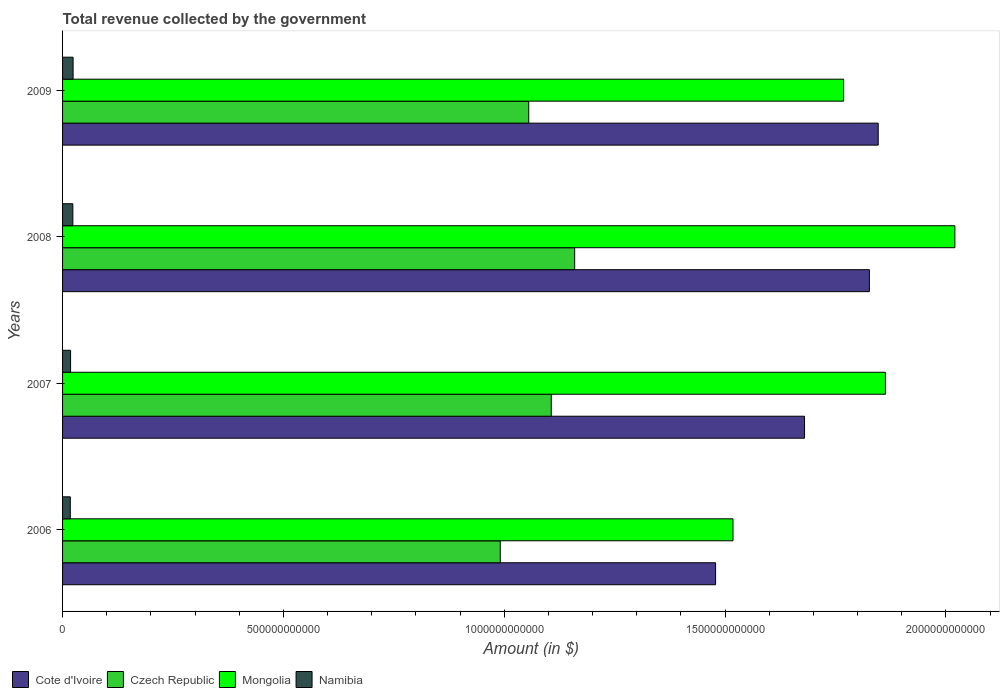How many different coloured bars are there?
Provide a succinct answer. 4. What is the total revenue collected by the government in Cote d'Ivoire in 2009?
Your answer should be very brief. 1.85e+12. Across all years, what is the maximum total revenue collected by the government in Mongolia?
Your response must be concise. 2.02e+12. Across all years, what is the minimum total revenue collected by the government in Czech Republic?
Offer a terse response. 9.91e+11. What is the total total revenue collected by the government in Czech Republic in the graph?
Provide a succinct answer. 4.31e+12. What is the difference between the total revenue collected by the government in Czech Republic in 2007 and that in 2008?
Give a very brief answer. -5.30e+1. What is the difference between the total revenue collected by the government in Cote d'Ivoire in 2006 and the total revenue collected by the government in Mongolia in 2007?
Keep it short and to the point. -3.84e+11. What is the average total revenue collected by the government in Cote d'Ivoire per year?
Ensure brevity in your answer.  1.71e+12. In the year 2008, what is the difference between the total revenue collected by the government in Cote d'Ivoire and total revenue collected by the government in Czech Republic?
Provide a short and direct response. 6.67e+11. In how many years, is the total revenue collected by the government in Mongolia greater than 300000000000 $?
Make the answer very short. 4. What is the ratio of the total revenue collected by the government in Cote d'Ivoire in 2008 to that in 2009?
Give a very brief answer. 0.99. Is the total revenue collected by the government in Czech Republic in 2007 less than that in 2008?
Ensure brevity in your answer.  Yes. What is the difference between the highest and the second highest total revenue collected by the government in Czech Republic?
Keep it short and to the point. 5.30e+1. What is the difference between the highest and the lowest total revenue collected by the government in Mongolia?
Your response must be concise. 5.02e+11. In how many years, is the total revenue collected by the government in Namibia greater than the average total revenue collected by the government in Namibia taken over all years?
Keep it short and to the point. 2. Is the sum of the total revenue collected by the government in Cote d'Ivoire in 2007 and 2009 greater than the maximum total revenue collected by the government in Mongolia across all years?
Offer a terse response. Yes. Is it the case that in every year, the sum of the total revenue collected by the government in Namibia and total revenue collected by the government in Czech Republic is greater than the sum of total revenue collected by the government in Cote d'Ivoire and total revenue collected by the government in Mongolia?
Your response must be concise. No. What does the 1st bar from the top in 2006 represents?
Offer a terse response. Namibia. What does the 3rd bar from the bottom in 2007 represents?
Provide a short and direct response. Mongolia. How many bars are there?
Provide a succinct answer. 16. How many years are there in the graph?
Provide a short and direct response. 4. What is the difference between two consecutive major ticks on the X-axis?
Your answer should be very brief. 5.00e+11. Are the values on the major ticks of X-axis written in scientific E-notation?
Your response must be concise. No. Does the graph contain any zero values?
Ensure brevity in your answer.  No. Does the graph contain grids?
Your answer should be compact. No. Where does the legend appear in the graph?
Provide a short and direct response. Bottom left. What is the title of the graph?
Ensure brevity in your answer.  Total revenue collected by the government. Does "Euro area" appear as one of the legend labels in the graph?
Make the answer very short. No. What is the label or title of the X-axis?
Your answer should be very brief. Amount (in $). What is the Amount (in $) of Cote d'Ivoire in 2006?
Keep it short and to the point. 1.48e+12. What is the Amount (in $) of Czech Republic in 2006?
Offer a terse response. 9.91e+11. What is the Amount (in $) in Mongolia in 2006?
Offer a very short reply. 1.52e+12. What is the Amount (in $) in Namibia in 2006?
Your answer should be very brief. 1.75e+1. What is the Amount (in $) in Cote d'Ivoire in 2007?
Provide a short and direct response. 1.68e+12. What is the Amount (in $) in Czech Republic in 2007?
Keep it short and to the point. 1.11e+12. What is the Amount (in $) in Mongolia in 2007?
Provide a succinct answer. 1.86e+12. What is the Amount (in $) in Namibia in 2007?
Keep it short and to the point. 1.82e+1. What is the Amount (in $) in Cote d'Ivoire in 2008?
Offer a very short reply. 1.83e+12. What is the Amount (in $) of Czech Republic in 2008?
Provide a succinct answer. 1.16e+12. What is the Amount (in $) of Mongolia in 2008?
Your response must be concise. 2.02e+12. What is the Amount (in $) in Namibia in 2008?
Give a very brief answer. 2.33e+1. What is the Amount (in $) in Cote d'Ivoire in 2009?
Provide a succinct answer. 1.85e+12. What is the Amount (in $) of Czech Republic in 2009?
Provide a short and direct response. 1.06e+12. What is the Amount (in $) in Mongolia in 2009?
Ensure brevity in your answer.  1.77e+12. What is the Amount (in $) in Namibia in 2009?
Make the answer very short. 2.38e+1. Across all years, what is the maximum Amount (in $) in Cote d'Ivoire?
Give a very brief answer. 1.85e+12. Across all years, what is the maximum Amount (in $) of Czech Republic?
Ensure brevity in your answer.  1.16e+12. Across all years, what is the maximum Amount (in $) of Mongolia?
Your answer should be very brief. 2.02e+12. Across all years, what is the maximum Amount (in $) of Namibia?
Ensure brevity in your answer.  2.38e+1. Across all years, what is the minimum Amount (in $) in Cote d'Ivoire?
Make the answer very short. 1.48e+12. Across all years, what is the minimum Amount (in $) of Czech Republic?
Ensure brevity in your answer.  9.91e+11. Across all years, what is the minimum Amount (in $) in Mongolia?
Keep it short and to the point. 1.52e+12. Across all years, what is the minimum Amount (in $) of Namibia?
Provide a succinct answer. 1.75e+1. What is the total Amount (in $) of Cote d'Ivoire in the graph?
Give a very brief answer. 6.83e+12. What is the total Amount (in $) in Czech Republic in the graph?
Keep it short and to the point. 4.31e+12. What is the total Amount (in $) of Mongolia in the graph?
Offer a terse response. 7.17e+12. What is the total Amount (in $) in Namibia in the graph?
Your response must be concise. 8.28e+1. What is the difference between the Amount (in $) in Cote d'Ivoire in 2006 and that in 2007?
Make the answer very short. -2.01e+11. What is the difference between the Amount (in $) of Czech Republic in 2006 and that in 2007?
Offer a terse response. -1.15e+11. What is the difference between the Amount (in $) of Mongolia in 2006 and that in 2007?
Your answer should be very brief. -3.45e+11. What is the difference between the Amount (in $) in Namibia in 2006 and that in 2007?
Make the answer very short. -6.34e+08. What is the difference between the Amount (in $) of Cote d'Ivoire in 2006 and that in 2008?
Your response must be concise. -3.48e+11. What is the difference between the Amount (in $) of Czech Republic in 2006 and that in 2008?
Give a very brief answer. -1.68e+11. What is the difference between the Amount (in $) of Mongolia in 2006 and that in 2008?
Make the answer very short. -5.02e+11. What is the difference between the Amount (in $) of Namibia in 2006 and that in 2008?
Your answer should be very brief. -5.80e+09. What is the difference between the Amount (in $) of Cote d'Ivoire in 2006 and that in 2009?
Your answer should be very brief. -3.68e+11. What is the difference between the Amount (in $) of Czech Republic in 2006 and that in 2009?
Offer a terse response. -6.45e+1. What is the difference between the Amount (in $) of Mongolia in 2006 and that in 2009?
Ensure brevity in your answer.  -2.51e+11. What is the difference between the Amount (in $) in Namibia in 2006 and that in 2009?
Provide a succinct answer. -6.33e+09. What is the difference between the Amount (in $) of Cote d'Ivoire in 2007 and that in 2008?
Ensure brevity in your answer.  -1.47e+11. What is the difference between the Amount (in $) in Czech Republic in 2007 and that in 2008?
Make the answer very short. -5.30e+1. What is the difference between the Amount (in $) in Mongolia in 2007 and that in 2008?
Make the answer very short. -1.57e+11. What is the difference between the Amount (in $) in Namibia in 2007 and that in 2008?
Offer a very short reply. -5.16e+09. What is the difference between the Amount (in $) in Cote d'Ivoire in 2007 and that in 2009?
Offer a terse response. -1.67e+11. What is the difference between the Amount (in $) in Czech Republic in 2007 and that in 2009?
Your answer should be compact. 5.09e+1. What is the difference between the Amount (in $) of Mongolia in 2007 and that in 2009?
Make the answer very short. 9.45e+1. What is the difference between the Amount (in $) in Namibia in 2007 and that in 2009?
Your answer should be very brief. -5.70e+09. What is the difference between the Amount (in $) of Cote d'Ivoire in 2008 and that in 2009?
Provide a short and direct response. -2.00e+1. What is the difference between the Amount (in $) in Czech Republic in 2008 and that in 2009?
Provide a succinct answer. 1.04e+11. What is the difference between the Amount (in $) of Mongolia in 2008 and that in 2009?
Your answer should be very brief. 2.52e+11. What is the difference between the Amount (in $) in Namibia in 2008 and that in 2009?
Make the answer very short. -5.30e+08. What is the difference between the Amount (in $) of Cote d'Ivoire in 2006 and the Amount (in $) of Czech Republic in 2007?
Your response must be concise. 3.72e+11. What is the difference between the Amount (in $) in Cote d'Ivoire in 2006 and the Amount (in $) in Mongolia in 2007?
Make the answer very short. -3.84e+11. What is the difference between the Amount (in $) in Cote d'Ivoire in 2006 and the Amount (in $) in Namibia in 2007?
Give a very brief answer. 1.46e+12. What is the difference between the Amount (in $) of Czech Republic in 2006 and the Amount (in $) of Mongolia in 2007?
Your response must be concise. -8.72e+11. What is the difference between the Amount (in $) of Czech Republic in 2006 and the Amount (in $) of Namibia in 2007?
Your response must be concise. 9.73e+11. What is the difference between the Amount (in $) of Mongolia in 2006 and the Amount (in $) of Namibia in 2007?
Make the answer very short. 1.50e+12. What is the difference between the Amount (in $) of Cote d'Ivoire in 2006 and the Amount (in $) of Czech Republic in 2008?
Keep it short and to the point. 3.19e+11. What is the difference between the Amount (in $) in Cote d'Ivoire in 2006 and the Amount (in $) in Mongolia in 2008?
Give a very brief answer. -5.42e+11. What is the difference between the Amount (in $) in Cote d'Ivoire in 2006 and the Amount (in $) in Namibia in 2008?
Your answer should be very brief. 1.46e+12. What is the difference between the Amount (in $) in Czech Republic in 2006 and the Amount (in $) in Mongolia in 2008?
Offer a terse response. -1.03e+12. What is the difference between the Amount (in $) in Czech Republic in 2006 and the Amount (in $) in Namibia in 2008?
Offer a terse response. 9.68e+11. What is the difference between the Amount (in $) of Mongolia in 2006 and the Amount (in $) of Namibia in 2008?
Provide a succinct answer. 1.49e+12. What is the difference between the Amount (in $) in Cote d'Ivoire in 2006 and the Amount (in $) in Czech Republic in 2009?
Give a very brief answer. 4.23e+11. What is the difference between the Amount (in $) in Cote d'Ivoire in 2006 and the Amount (in $) in Mongolia in 2009?
Your answer should be compact. -2.90e+11. What is the difference between the Amount (in $) of Cote d'Ivoire in 2006 and the Amount (in $) of Namibia in 2009?
Offer a terse response. 1.45e+12. What is the difference between the Amount (in $) in Czech Republic in 2006 and the Amount (in $) in Mongolia in 2009?
Ensure brevity in your answer.  -7.77e+11. What is the difference between the Amount (in $) of Czech Republic in 2006 and the Amount (in $) of Namibia in 2009?
Your answer should be very brief. 9.67e+11. What is the difference between the Amount (in $) in Mongolia in 2006 and the Amount (in $) in Namibia in 2009?
Give a very brief answer. 1.49e+12. What is the difference between the Amount (in $) in Cote d'Ivoire in 2007 and the Amount (in $) in Czech Republic in 2008?
Make the answer very short. 5.20e+11. What is the difference between the Amount (in $) in Cote d'Ivoire in 2007 and the Amount (in $) in Mongolia in 2008?
Offer a terse response. -3.40e+11. What is the difference between the Amount (in $) in Cote d'Ivoire in 2007 and the Amount (in $) in Namibia in 2008?
Offer a very short reply. 1.66e+12. What is the difference between the Amount (in $) of Czech Republic in 2007 and the Amount (in $) of Mongolia in 2008?
Make the answer very short. -9.14e+11. What is the difference between the Amount (in $) of Czech Republic in 2007 and the Amount (in $) of Namibia in 2008?
Your answer should be compact. 1.08e+12. What is the difference between the Amount (in $) of Mongolia in 2007 and the Amount (in $) of Namibia in 2008?
Give a very brief answer. 1.84e+12. What is the difference between the Amount (in $) in Cote d'Ivoire in 2007 and the Amount (in $) in Czech Republic in 2009?
Ensure brevity in your answer.  6.24e+11. What is the difference between the Amount (in $) of Cote d'Ivoire in 2007 and the Amount (in $) of Mongolia in 2009?
Give a very brief answer. -8.85e+1. What is the difference between the Amount (in $) in Cote d'Ivoire in 2007 and the Amount (in $) in Namibia in 2009?
Your answer should be compact. 1.66e+12. What is the difference between the Amount (in $) of Czech Republic in 2007 and the Amount (in $) of Mongolia in 2009?
Your answer should be compact. -6.62e+11. What is the difference between the Amount (in $) of Czech Republic in 2007 and the Amount (in $) of Namibia in 2009?
Your answer should be compact. 1.08e+12. What is the difference between the Amount (in $) of Mongolia in 2007 and the Amount (in $) of Namibia in 2009?
Provide a succinct answer. 1.84e+12. What is the difference between the Amount (in $) of Cote d'Ivoire in 2008 and the Amount (in $) of Czech Republic in 2009?
Offer a terse response. 7.71e+11. What is the difference between the Amount (in $) of Cote d'Ivoire in 2008 and the Amount (in $) of Mongolia in 2009?
Give a very brief answer. 5.83e+1. What is the difference between the Amount (in $) in Cote d'Ivoire in 2008 and the Amount (in $) in Namibia in 2009?
Your answer should be compact. 1.80e+12. What is the difference between the Amount (in $) of Czech Republic in 2008 and the Amount (in $) of Mongolia in 2009?
Keep it short and to the point. -6.09e+11. What is the difference between the Amount (in $) in Czech Republic in 2008 and the Amount (in $) in Namibia in 2009?
Provide a short and direct response. 1.14e+12. What is the difference between the Amount (in $) in Mongolia in 2008 and the Amount (in $) in Namibia in 2009?
Keep it short and to the point. 2.00e+12. What is the average Amount (in $) in Cote d'Ivoire per year?
Give a very brief answer. 1.71e+12. What is the average Amount (in $) of Czech Republic per year?
Provide a short and direct response. 1.08e+12. What is the average Amount (in $) in Mongolia per year?
Offer a terse response. 1.79e+12. What is the average Amount (in $) in Namibia per year?
Your response must be concise. 2.07e+1. In the year 2006, what is the difference between the Amount (in $) of Cote d'Ivoire and Amount (in $) of Czech Republic?
Offer a terse response. 4.88e+11. In the year 2006, what is the difference between the Amount (in $) in Cote d'Ivoire and Amount (in $) in Mongolia?
Offer a very short reply. -3.94e+1. In the year 2006, what is the difference between the Amount (in $) in Cote d'Ivoire and Amount (in $) in Namibia?
Your answer should be compact. 1.46e+12. In the year 2006, what is the difference between the Amount (in $) in Czech Republic and Amount (in $) in Mongolia?
Make the answer very short. -5.27e+11. In the year 2006, what is the difference between the Amount (in $) in Czech Republic and Amount (in $) in Namibia?
Your response must be concise. 9.73e+11. In the year 2006, what is the difference between the Amount (in $) in Mongolia and Amount (in $) in Namibia?
Ensure brevity in your answer.  1.50e+12. In the year 2007, what is the difference between the Amount (in $) in Cote d'Ivoire and Amount (in $) in Czech Republic?
Your response must be concise. 5.73e+11. In the year 2007, what is the difference between the Amount (in $) in Cote d'Ivoire and Amount (in $) in Mongolia?
Provide a succinct answer. -1.83e+11. In the year 2007, what is the difference between the Amount (in $) of Cote d'Ivoire and Amount (in $) of Namibia?
Offer a very short reply. 1.66e+12. In the year 2007, what is the difference between the Amount (in $) of Czech Republic and Amount (in $) of Mongolia?
Make the answer very short. -7.57e+11. In the year 2007, what is the difference between the Amount (in $) in Czech Republic and Amount (in $) in Namibia?
Provide a short and direct response. 1.09e+12. In the year 2007, what is the difference between the Amount (in $) in Mongolia and Amount (in $) in Namibia?
Keep it short and to the point. 1.84e+12. In the year 2008, what is the difference between the Amount (in $) in Cote d'Ivoire and Amount (in $) in Czech Republic?
Offer a very short reply. 6.67e+11. In the year 2008, what is the difference between the Amount (in $) in Cote d'Ivoire and Amount (in $) in Mongolia?
Offer a terse response. -1.94e+11. In the year 2008, what is the difference between the Amount (in $) of Cote d'Ivoire and Amount (in $) of Namibia?
Make the answer very short. 1.80e+12. In the year 2008, what is the difference between the Amount (in $) of Czech Republic and Amount (in $) of Mongolia?
Your response must be concise. -8.61e+11. In the year 2008, what is the difference between the Amount (in $) of Czech Republic and Amount (in $) of Namibia?
Make the answer very short. 1.14e+12. In the year 2008, what is the difference between the Amount (in $) in Mongolia and Amount (in $) in Namibia?
Ensure brevity in your answer.  2.00e+12. In the year 2009, what is the difference between the Amount (in $) of Cote d'Ivoire and Amount (in $) of Czech Republic?
Your answer should be compact. 7.91e+11. In the year 2009, what is the difference between the Amount (in $) of Cote d'Ivoire and Amount (in $) of Mongolia?
Make the answer very short. 7.83e+1. In the year 2009, what is the difference between the Amount (in $) of Cote d'Ivoire and Amount (in $) of Namibia?
Offer a terse response. 1.82e+12. In the year 2009, what is the difference between the Amount (in $) of Czech Republic and Amount (in $) of Mongolia?
Ensure brevity in your answer.  -7.13e+11. In the year 2009, what is the difference between the Amount (in $) of Czech Republic and Amount (in $) of Namibia?
Provide a short and direct response. 1.03e+12. In the year 2009, what is the difference between the Amount (in $) in Mongolia and Amount (in $) in Namibia?
Your response must be concise. 1.74e+12. What is the ratio of the Amount (in $) of Cote d'Ivoire in 2006 to that in 2007?
Provide a short and direct response. 0.88. What is the ratio of the Amount (in $) in Czech Republic in 2006 to that in 2007?
Provide a succinct answer. 0.9. What is the ratio of the Amount (in $) of Mongolia in 2006 to that in 2007?
Offer a very short reply. 0.81. What is the ratio of the Amount (in $) in Namibia in 2006 to that in 2007?
Keep it short and to the point. 0.97. What is the ratio of the Amount (in $) in Cote d'Ivoire in 2006 to that in 2008?
Your response must be concise. 0.81. What is the ratio of the Amount (in $) of Czech Republic in 2006 to that in 2008?
Give a very brief answer. 0.85. What is the ratio of the Amount (in $) in Mongolia in 2006 to that in 2008?
Your answer should be very brief. 0.75. What is the ratio of the Amount (in $) in Namibia in 2006 to that in 2008?
Provide a succinct answer. 0.75. What is the ratio of the Amount (in $) in Cote d'Ivoire in 2006 to that in 2009?
Make the answer very short. 0.8. What is the ratio of the Amount (in $) of Czech Republic in 2006 to that in 2009?
Your response must be concise. 0.94. What is the ratio of the Amount (in $) of Mongolia in 2006 to that in 2009?
Give a very brief answer. 0.86. What is the ratio of the Amount (in $) in Namibia in 2006 to that in 2009?
Ensure brevity in your answer.  0.73. What is the ratio of the Amount (in $) in Cote d'Ivoire in 2007 to that in 2008?
Offer a terse response. 0.92. What is the ratio of the Amount (in $) in Czech Republic in 2007 to that in 2008?
Provide a succinct answer. 0.95. What is the ratio of the Amount (in $) of Mongolia in 2007 to that in 2008?
Your response must be concise. 0.92. What is the ratio of the Amount (in $) of Namibia in 2007 to that in 2008?
Provide a short and direct response. 0.78. What is the ratio of the Amount (in $) in Cote d'Ivoire in 2007 to that in 2009?
Offer a terse response. 0.91. What is the ratio of the Amount (in $) in Czech Republic in 2007 to that in 2009?
Provide a short and direct response. 1.05. What is the ratio of the Amount (in $) in Mongolia in 2007 to that in 2009?
Your response must be concise. 1.05. What is the ratio of the Amount (in $) in Namibia in 2007 to that in 2009?
Your response must be concise. 0.76. What is the ratio of the Amount (in $) in Cote d'Ivoire in 2008 to that in 2009?
Your response must be concise. 0.99. What is the ratio of the Amount (in $) of Czech Republic in 2008 to that in 2009?
Make the answer very short. 1.1. What is the ratio of the Amount (in $) of Mongolia in 2008 to that in 2009?
Keep it short and to the point. 1.14. What is the ratio of the Amount (in $) in Namibia in 2008 to that in 2009?
Provide a short and direct response. 0.98. What is the difference between the highest and the second highest Amount (in $) in Cote d'Ivoire?
Ensure brevity in your answer.  2.00e+1. What is the difference between the highest and the second highest Amount (in $) of Czech Republic?
Give a very brief answer. 5.30e+1. What is the difference between the highest and the second highest Amount (in $) in Mongolia?
Your response must be concise. 1.57e+11. What is the difference between the highest and the second highest Amount (in $) in Namibia?
Offer a very short reply. 5.30e+08. What is the difference between the highest and the lowest Amount (in $) in Cote d'Ivoire?
Your answer should be very brief. 3.68e+11. What is the difference between the highest and the lowest Amount (in $) in Czech Republic?
Offer a terse response. 1.68e+11. What is the difference between the highest and the lowest Amount (in $) of Mongolia?
Your answer should be very brief. 5.02e+11. What is the difference between the highest and the lowest Amount (in $) of Namibia?
Give a very brief answer. 6.33e+09. 